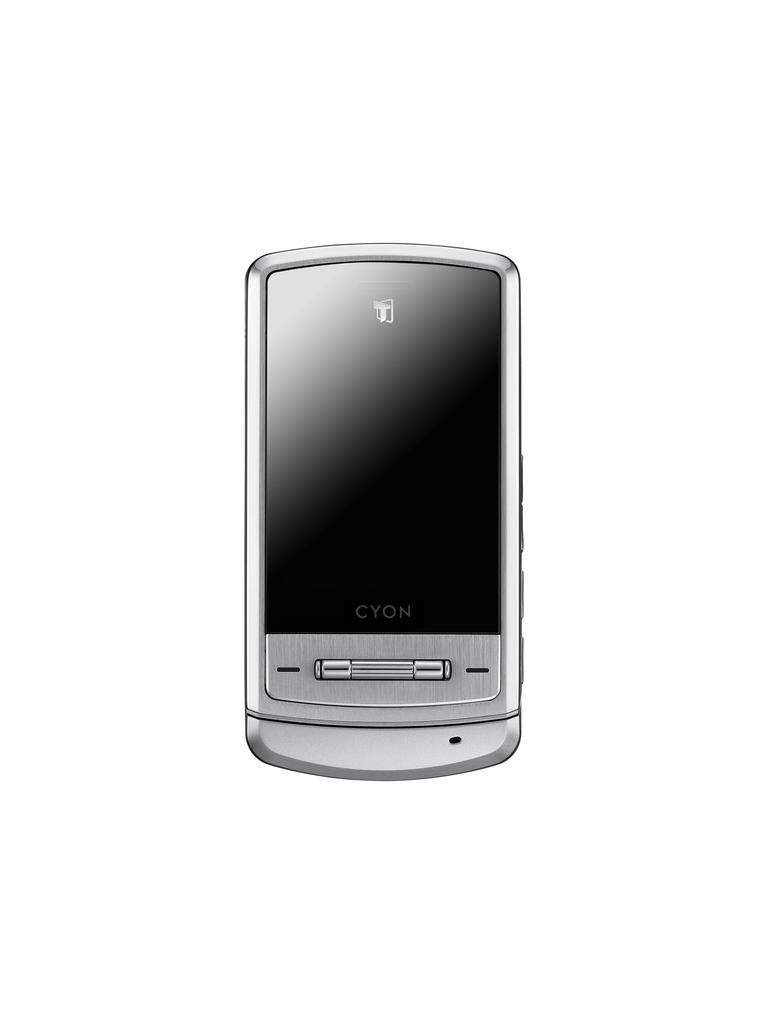<image>
Give a short and clear explanation of the subsequent image. An oldish looking cell phone with Cyon written on it 